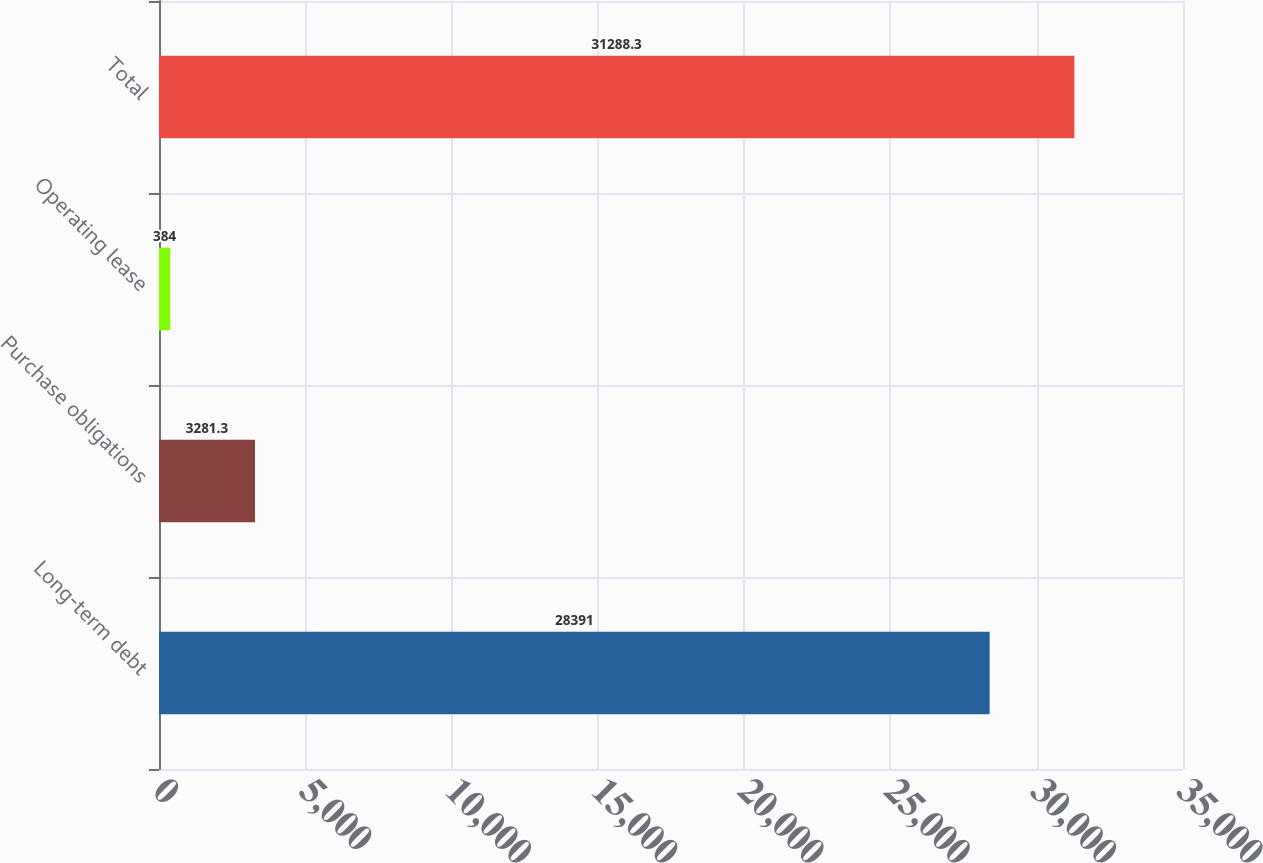Convert chart to OTSL. <chart><loc_0><loc_0><loc_500><loc_500><bar_chart><fcel>Long-term debt<fcel>Purchase obligations<fcel>Operating lease<fcel>Total<nl><fcel>28391<fcel>3281.3<fcel>384<fcel>31288.3<nl></chart> 